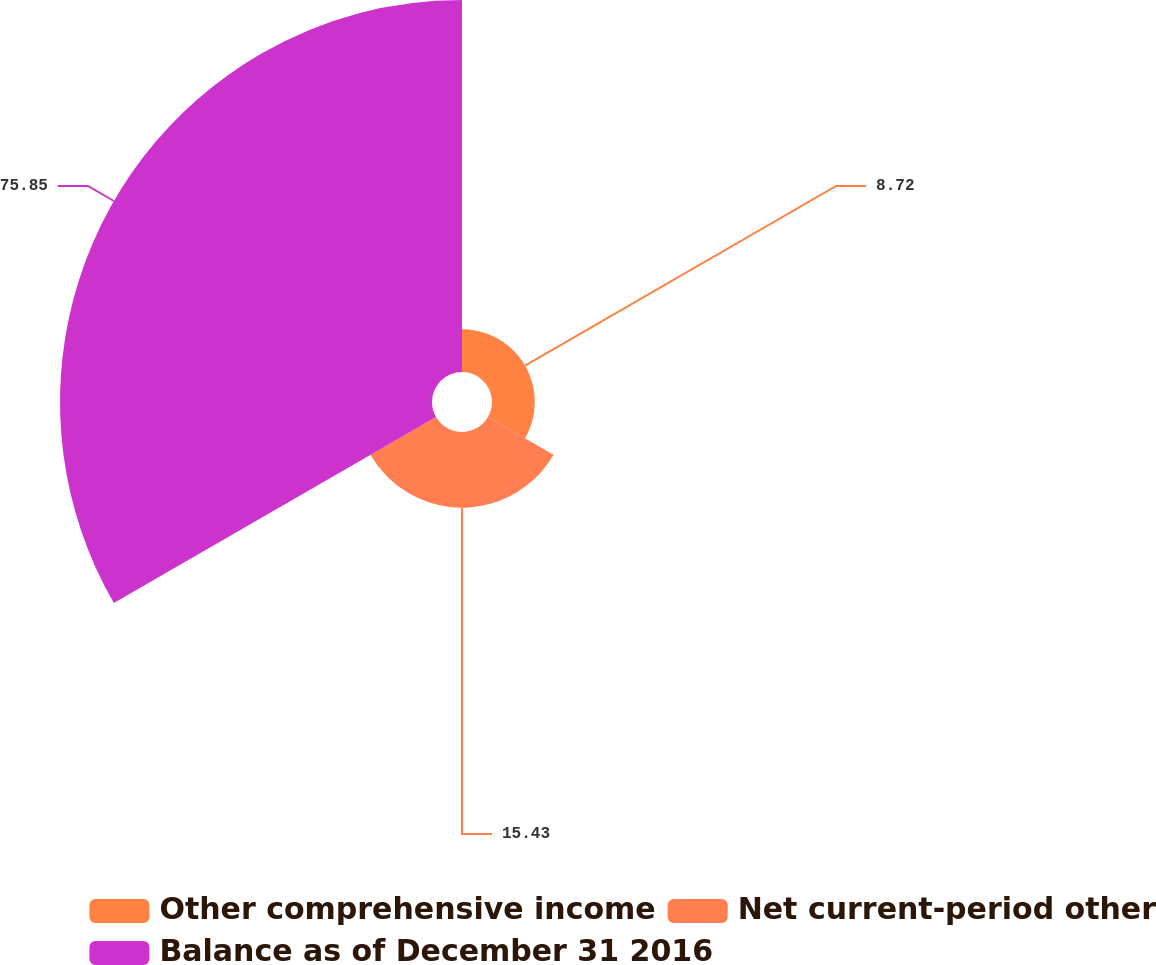Convert chart to OTSL. <chart><loc_0><loc_0><loc_500><loc_500><pie_chart><fcel>Other comprehensive income<fcel>Net current-period other<fcel>Balance as of December 31 2016<nl><fcel>8.72%<fcel>15.43%<fcel>75.85%<nl></chart> 